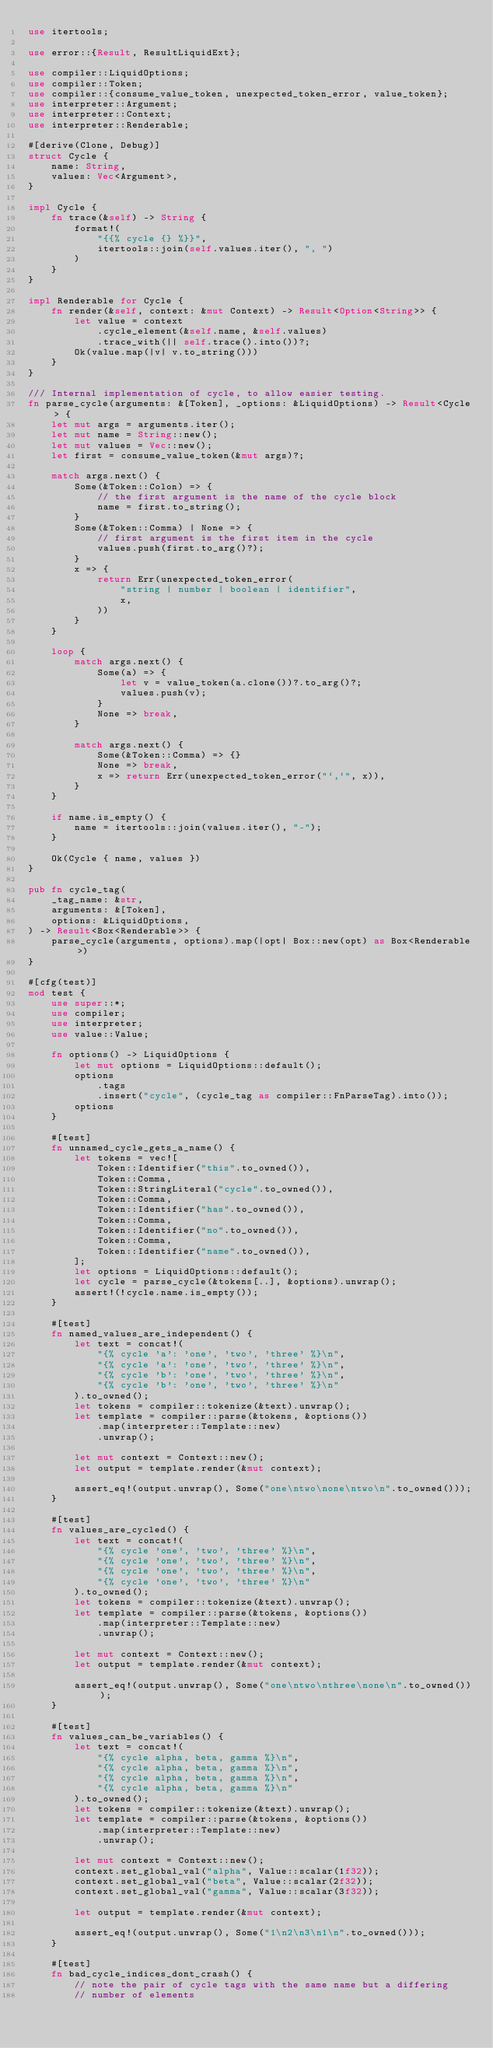<code> <loc_0><loc_0><loc_500><loc_500><_Rust_>use itertools;

use error::{Result, ResultLiquidExt};

use compiler::LiquidOptions;
use compiler::Token;
use compiler::{consume_value_token, unexpected_token_error, value_token};
use interpreter::Argument;
use interpreter::Context;
use interpreter::Renderable;

#[derive(Clone, Debug)]
struct Cycle {
    name: String,
    values: Vec<Argument>,
}

impl Cycle {
    fn trace(&self) -> String {
        format!(
            "{{% cycle {} %}}",
            itertools::join(self.values.iter(), ", ")
        )
    }
}

impl Renderable for Cycle {
    fn render(&self, context: &mut Context) -> Result<Option<String>> {
        let value = context
            .cycle_element(&self.name, &self.values)
            .trace_with(|| self.trace().into())?;
        Ok(value.map(|v| v.to_string()))
    }
}

/// Internal implementation of cycle, to allow easier testing.
fn parse_cycle(arguments: &[Token], _options: &LiquidOptions) -> Result<Cycle> {
    let mut args = arguments.iter();
    let mut name = String::new();
    let mut values = Vec::new();
    let first = consume_value_token(&mut args)?;

    match args.next() {
        Some(&Token::Colon) => {
            // the first argument is the name of the cycle block
            name = first.to_string();
        }
        Some(&Token::Comma) | None => {
            // first argument is the first item in the cycle
            values.push(first.to_arg()?);
        }
        x => {
            return Err(unexpected_token_error(
                "string | number | boolean | identifier",
                x,
            ))
        }
    }

    loop {
        match args.next() {
            Some(a) => {
                let v = value_token(a.clone())?.to_arg()?;
                values.push(v);
            }
            None => break,
        }

        match args.next() {
            Some(&Token::Comma) => {}
            None => break,
            x => return Err(unexpected_token_error("`,`", x)),
        }
    }

    if name.is_empty() {
        name = itertools::join(values.iter(), "-");
    }

    Ok(Cycle { name, values })
}

pub fn cycle_tag(
    _tag_name: &str,
    arguments: &[Token],
    options: &LiquidOptions,
) -> Result<Box<Renderable>> {
    parse_cycle(arguments, options).map(|opt| Box::new(opt) as Box<Renderable>)
}

#[cfg(test)]
mod test {
    use super::*;
    use compiler;
    use interpreter;
    use value::Value;

    fn options() -> LiquidOptions {
        let mut options = LiquidOptions::default();
        options
            .tags
            .insert("cycle", (cycle_tag as compiler::FnParseTag).into());
        options
    }

    #[test]
    fn unnamed_cycle_gets_a_name() {
        let tokens = vec![
            Token::Identifier("this".to_owned()),
            Token::Comma,
            Token::StringLiteral("cycle".to_owned()),
            Token::Comma,
            Token::Identifier("has".to_owned()),
            Token::Comma,
            Token::Identifier("no".to_owned()),
            Token::Comma,
            Token::Identifier("name".to_owned()),
        ];
        let options = LiquidOptions::default();
        let cycle = parse_cycle(&tokens[..], &options).unwrap();
        assert!(!cycle.name.is_empty());
    }

    #[test]
    fn named_values_are_independent() {
        let text = concat!(
            "{% cycle 'a': 'one', 'two', 'three' %}\n",
            "{% cycle 'a': 'one', 'two', 'three' %}\n",
            "{% cycle 'b': 'one', 'two', 'three' %}\n",
            "{% cycle 'b': 'one', 'two', 'three' %}\n"
        ).to_owned();
        let tokens = compiler::tokenize(&text).unwrap();
        let template = compiler::parse(&tokens, &options())
            .map(interpreter::Template::new)
            .unwrap();

        let mut context = Context::new();
        let output = template.render(&mut context);

        assert_eq!(output.unwrap(), Some("one\ntwo\none\ntwo\n".to_owned()));
    }

    #[test]
    fn values_are_cycled() {
        let text = concat!(
            "{% cycle 'one', 'two', 'three' %}\n",
            "{% cycle 'one', 'two', 'three' %}\n",
            "{% cycle 'one', 'two', 'three' %}\n",
            "{% cycle 'one', 'two', 'three' %}\n"
        ).to_owned();
        let tokens = compiler::tokenize(&text).unwrap();
        let template = compiler::parse(&tokens, &options())
            .map(interpreter::Template::new)
            .unwrap();

        let mut context = Context::new();
        let output = template.render(&mut context);

        assert_eq!(output.unwrap(), Some("one\ntwo\nthree\none\n".to_owned()));
    }

    #[test]
    fn values_can_be_variables() {
        let text = concat!(
            "{% cycle alpha, beta, gamma %}\n",
            "{% cycle alpha, beta, gamma %}\n",
            "{% cycle alpha, beta, gamma %}\n",
            "{% cycle alpha, beta, gamma %}\n"
        ).to_owned();
        let tokens = compiler::tokenize(&text).unwrap();
        let template = compiler::parse(&tokens, &options())
            .map(interpreter::Template::new)
            .unwrap();

        let mut context = Context::new();
        context.set_global_val("alpha", Value::scalar(1f32));
        context.set_global_val("beta", Value::scalar(2f32));
        context.set_global_val("gamma", Value::scalar(3f32));

        let output = template.render(&mut context);

        assert_eq!(output.unwrap(), Some("1\n2\n3\n1\n".to_owned()));
    }

    #[test]
    fn bad_cycle_indices_dont_crash() {
        // note the pair of cycle tags with the same name but a differing
        // number of elements</code> 